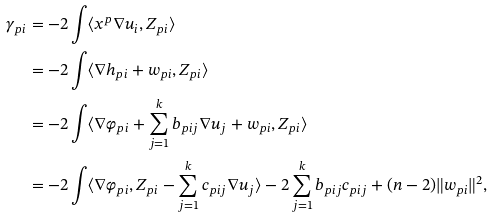Convert formula to latex. <formula><loc_0><loc_0><loc_500><loc_500>\gamma _ { p i } & = - 2 \int \langle x ^ { p } \nabla u _ { i } , Z _ { p i } \rangle \\ & = - 2 \int \langle \nabla h _ { p i } + { w } _ { p i } , Z _ { p i } \rangle \\ & = - 2 \int \langle \nabla \varphi _ { p i } + \sum _ { j = 1 } ^ { k } b _ { p i j } \nabla u _ { j } + { w } _ { p i } , Z _ { p i } \rangle \\ & = - 2 \int \langle \nabla \varphi _ { p i } , Z _ { p i } - \sum _ { j = 1 } ^ { k } c _ { p i j } \nabla u _ { j } \rangle - 2 \sum _ { j = 1 } ^ { k } b _ { p i j } c _ { p i j } + ( n - 2 ) \| { w } _ { p i } \| ^ { 2 } ,</formula> 